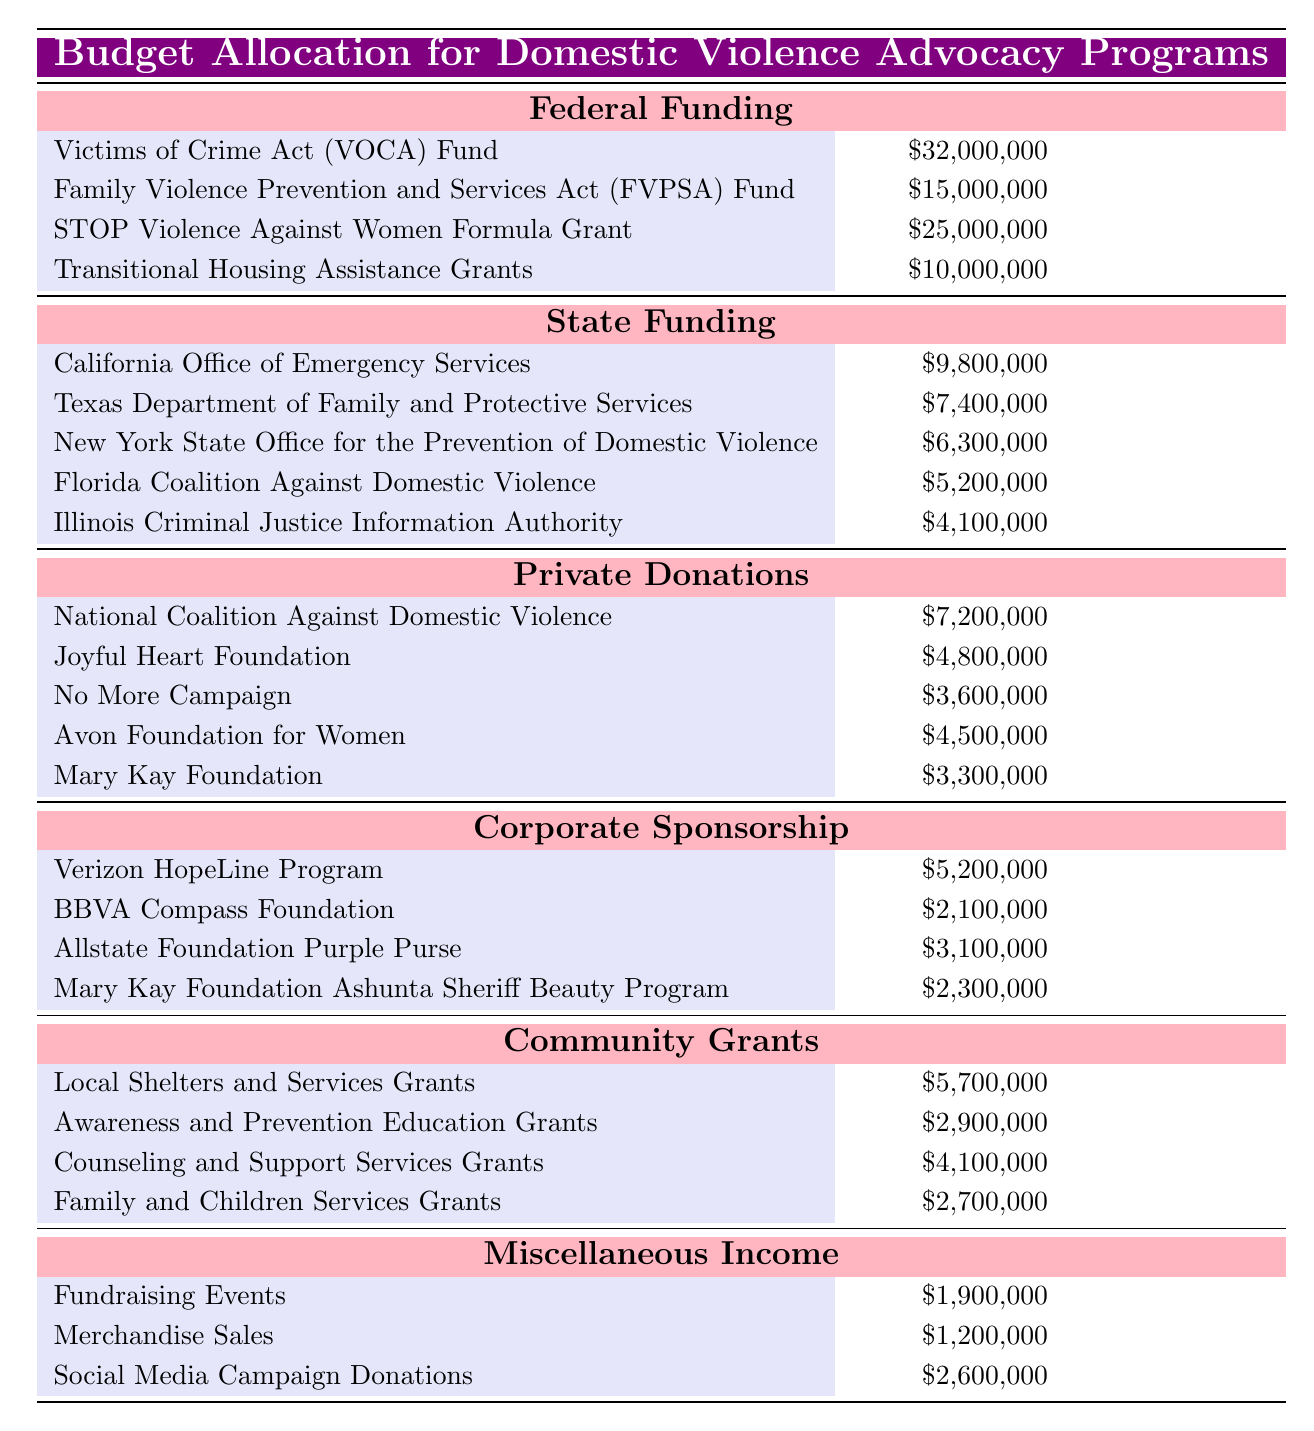What is the total federal funding allocated for domestic violence advocacy programs? To find the total federal funding, sum all the amounts listed under the "Federal Funding" category: 32,000,000 + 15,000,000 + 25,000,000 + 10,000,000 = 82,000,000.
Answer: 82,000,000 Which state receives the highest funding for domestic violence advocacy? From the "State Funding" section, California Office of Emergency Services has the highest allocation at 9,800,000.
Answer: California Office of Emergency Services Is the total amount of Private Donations greater than Corporate Sponsorship? First, sum the amounts in Private Donations: 7,200,000 + 4,800,000 + 3,600,000 + 4,500,000 + 3,300,000 = 23,400,000. Then sum Corporate Sponsorship: 5,200,000 + 2,100,000 + 3,100,000 + 2,300,000 = 12,700,000. Since 23,400,000 is greater than 12,700,000, the statement is true.
Answer: True What is the average funding provided by Community Grants? To calculate the average, sum the amounts in Community Grants: 5,700,000 + 2,900,000 + 4,100,000 + 2,700,000 = 15,400,000. There are four entries, so the average is 15,400,000 divided by 4, giving 3,850,000.
Answer: 3,850,000 How much funding does the Joyful Heart Foundation provide compared to the National Coalition Against Domestic Violence? The Joyful Heart Foundation provides 4,800,000 and the National Coalition Against Domestic Violence provides 7,200,000. So, 4,800,000 is less than 7,200,000, making it a smaller contribution.
Answer: Less than Which category has the least total funding and what is the amount? Sum the amounts in the "Miscellaneous Income" category: 1,900,000 + 1,200,000 + 2,600,000 = 5,700,000. This is the smallest total compared to others.
Answer: 5,700,000 What percentage of the total federal funding is allocated to the STOP Violence Against Women Formula Grant? The total federal funding is 82,000,000. The STOP grant amount is 25,000,000. To find the percentage, divide 25,000,000 by 82,000,000 and multiply by 100: (25,000,000 / 82,000,000) * 100 ≈ 30.49%.
Answer: Approximately 30.49% Which funding source contributes more, Federal Funding or Private Donations? Federal Funding totals 82,000,000 while Private Donations total 23,400,000. Since 82,000,000 is more than 23,400,000, Federal Funding contributes more.
Answer: Federal Funding How many more dollars does California's funding exceed Florida's funding? California receives 9,800,000 and Florida receives 5,200,000. The difference is calculated as 9,800,000 - 5,200,000 = 4,600,000.
Answer: 4,600,000 